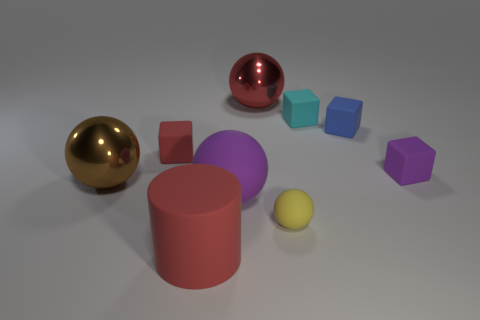Subtract 1 blocks. How many blocks are left? 3 Subtract all spheres. How many objects are left? 5 Add 8 green rubber objects. How many green rubber objects exist? 8 Subtract 0 purple cylinders. How many objects are left? 9 Subtract all large blue objects. Subtract all big purple matte things. How many objects are left? 8 Add 8 yellow matte balls. How many yellow matte balls are left? 9 